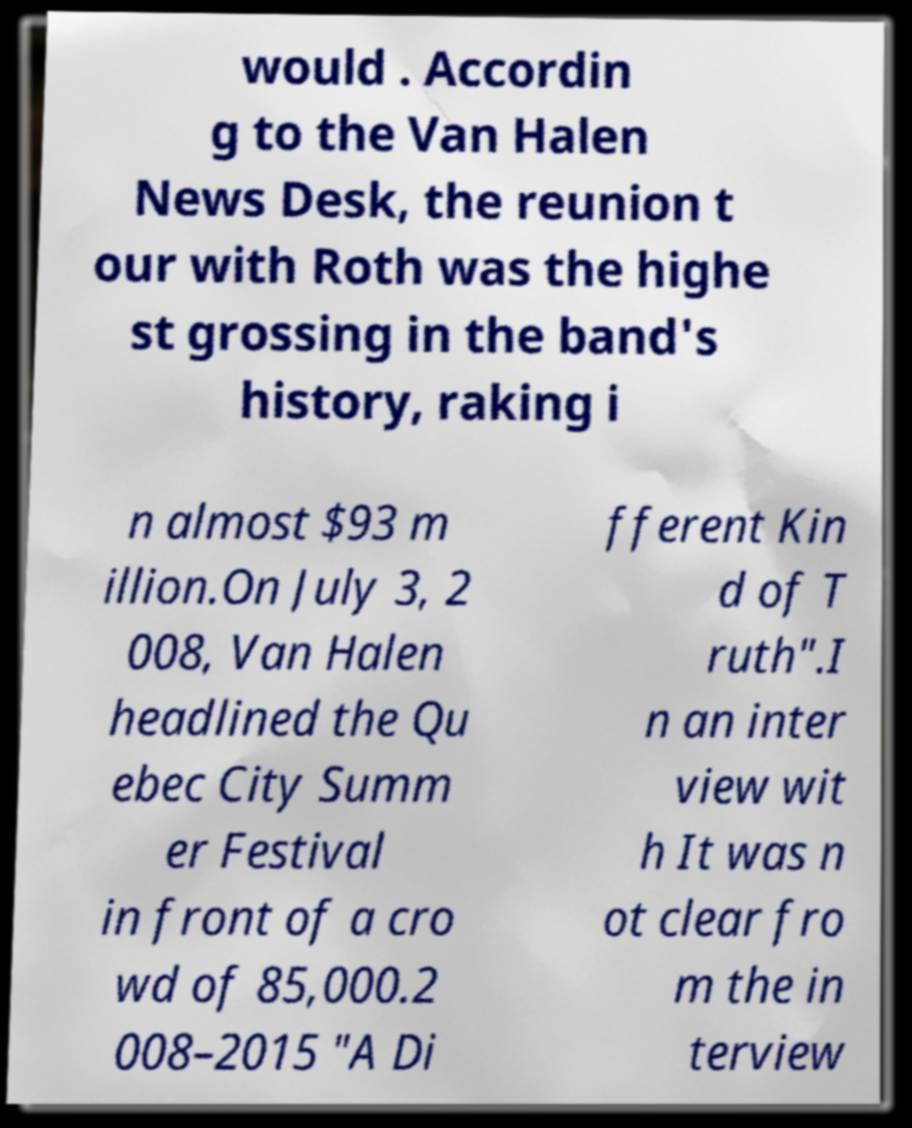There's text embedded in this image that I need extracted. Can you transcribe it verbatim? would . Accordin g to the Van Halen News Desk, the reunion t our with Roth was the highe st grossing in the band's history, raking i n almost $93 m illion.On July 3, 2 008, Van Halen headlined the Qu ebec City Summ er Festival in front of a cro wd of 85,000.2 008–2015 "A Di fferent Kin d of T ruth".I n an inter view wit h It was n ot clear fro m the in terview 